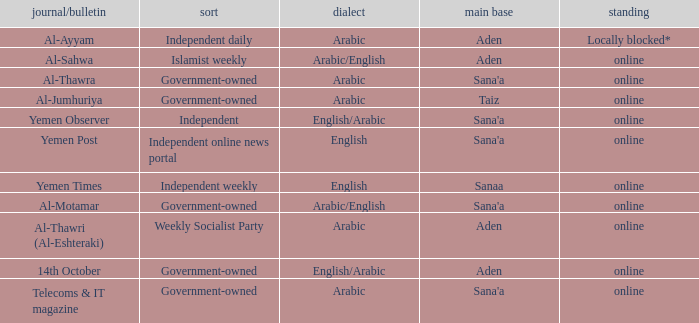What is Headquarter, when Language is English, and when Type is Independent Online News Portal? Sana'a. 